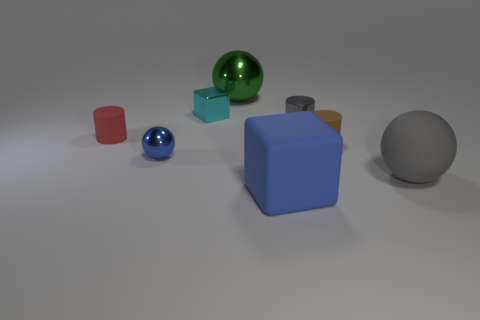Subtract all brown balls. Subtract all red cylinders. How many balls are left? 3 Add 2 tiny blue rubber cubes. How many objects exist? 10 Subtract all spheres. How many objects are left? 5 Add 2 small blue spheres. How many small blue spheres are left? 3 Add 3 cylinders. How many cylinders exist? 6 Subtract 0 purple balls. How many objects are left? 8 Subtract all tiny blue metal cubes. Subtract all tiny metal blocks. How many objects are left? 7 